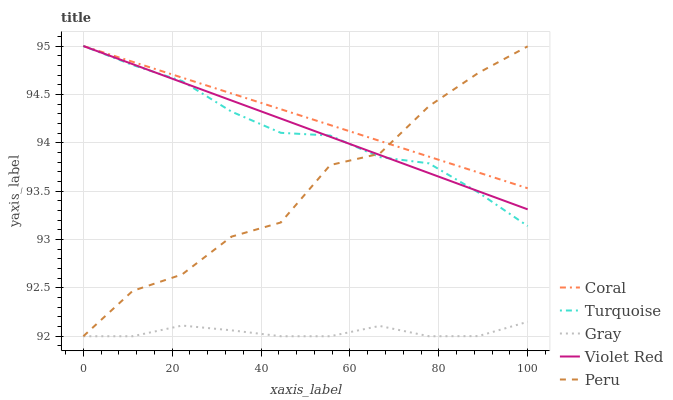Does Gray have the minimum area under the curve?
Answer yes or no. Yes. Does Coral have the maximum area under the curve?
Answer yes or no. Yes. Does Turquoise have the minimum area under the curve?
Answer yes or no. No. Does Turquoise have the maximum area under the curve?
Answer yes or no. No. Is Violet Red the smoothest?
Answer yes or no. Yes. Is Peru the roughest?
Answer yes or no. Yes. Is Coral the smoothest?
Answer yes or no. No. Is Coral the roughest?
Answer yes or no. No. Does Turquoise have the lowest value?
Answer yes or no. No. Does Violet Red have the highest value?
Answer yes or no. Yes. Does Peru have the highest value?
Answer yes or no. No. Is Gray less than Coral?
Answer yes or no. Yes. Is Coral greater than Gray?
Answer yes or no. Yes. Does Coral intersect Violet Red?
Answer yes or no. Yes. Is Coral less than Violet Red?
Answer yes or no. No. Is Coral greater than Violet Red?
Answer yes or no. No. Does Gray intersect Coral?
Answer yes or no. No. 